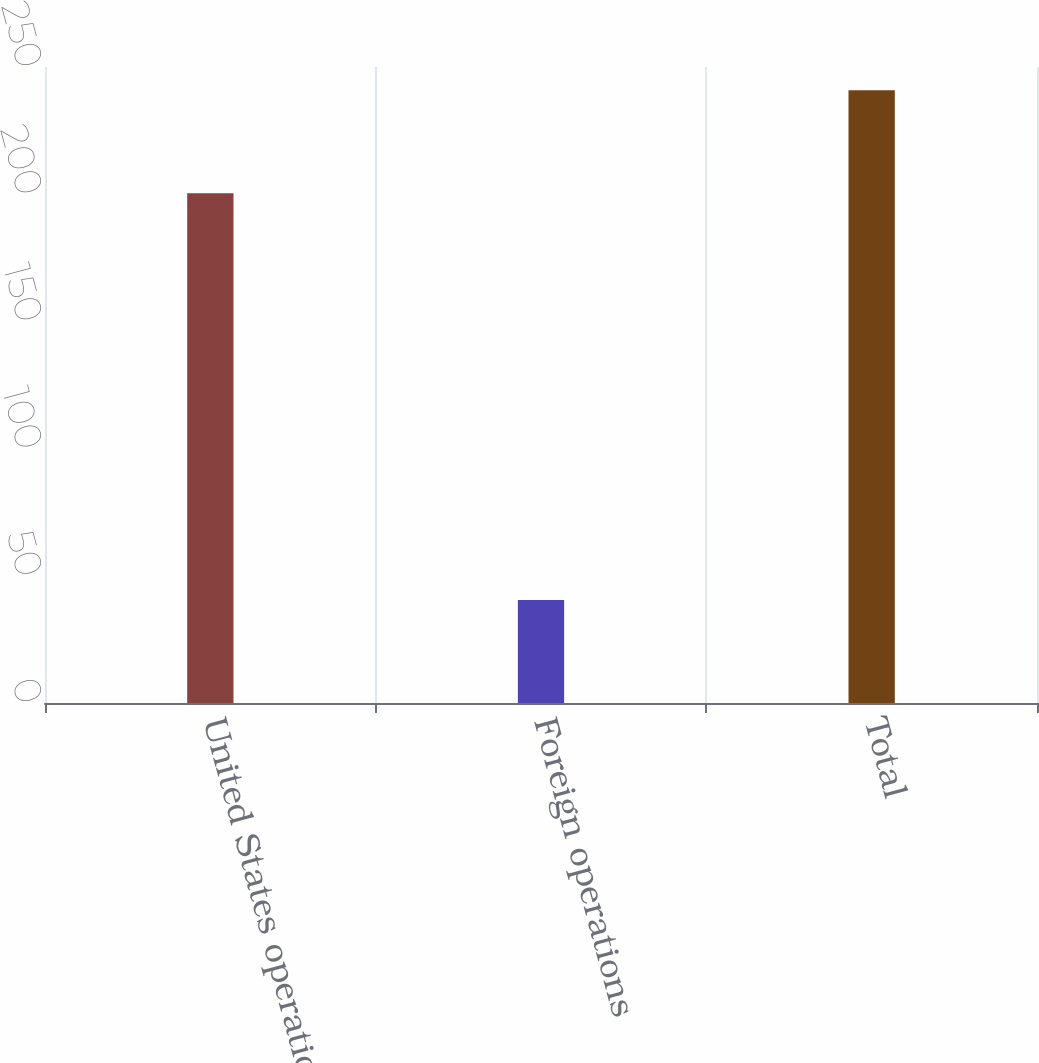Convert chart to OTSL. <chart><loc_0><loc_0><loc_500><loc_500><bar_chart><fcel>United States operations<fcel>Foreign operations<fcel>Total<nl><fcel>200.4<fcel>40.5<fcel>240.9<nl></chart> 